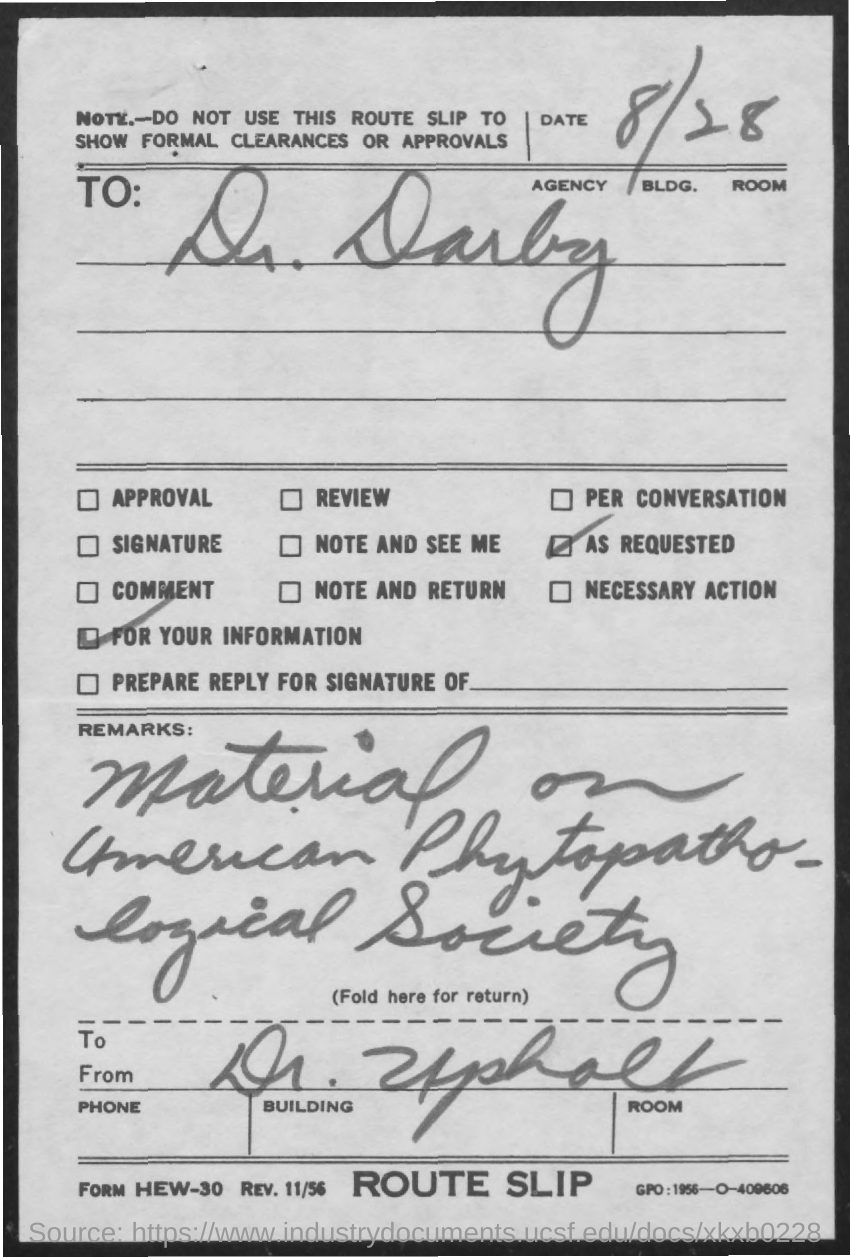What is the date mentioned in the route slip?
Give a very brief answer. 8/28. 